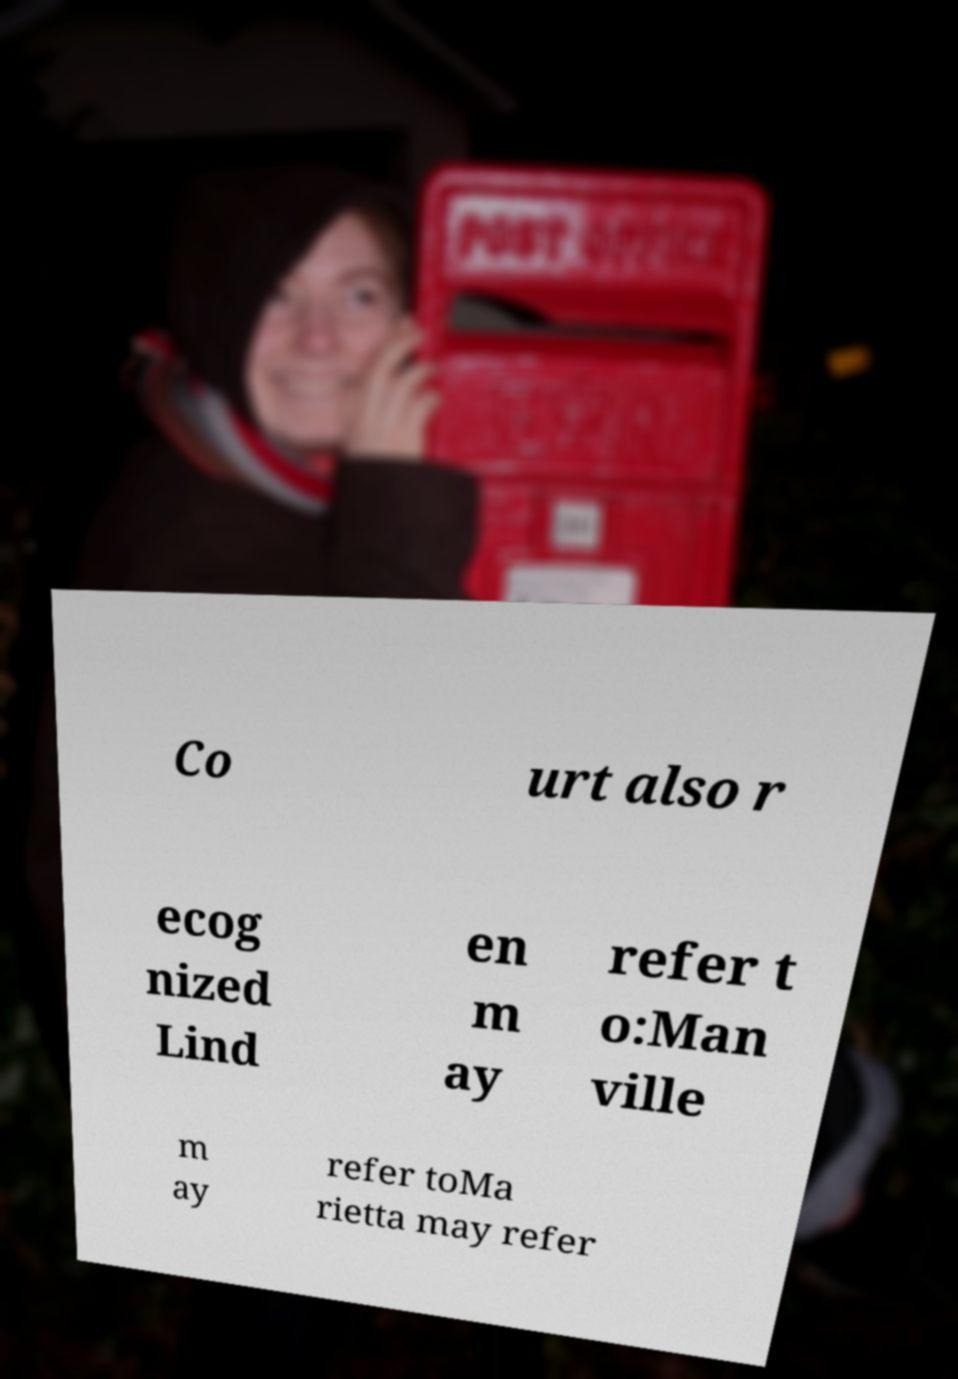Can you read and provide the text displayed in the image?This photo seems to have some interesting text. Can you extract and type it out for me? Co urt also r ecog nized Lind en m ay refer t o:Man ville m ay refer toMa rietta may refer 